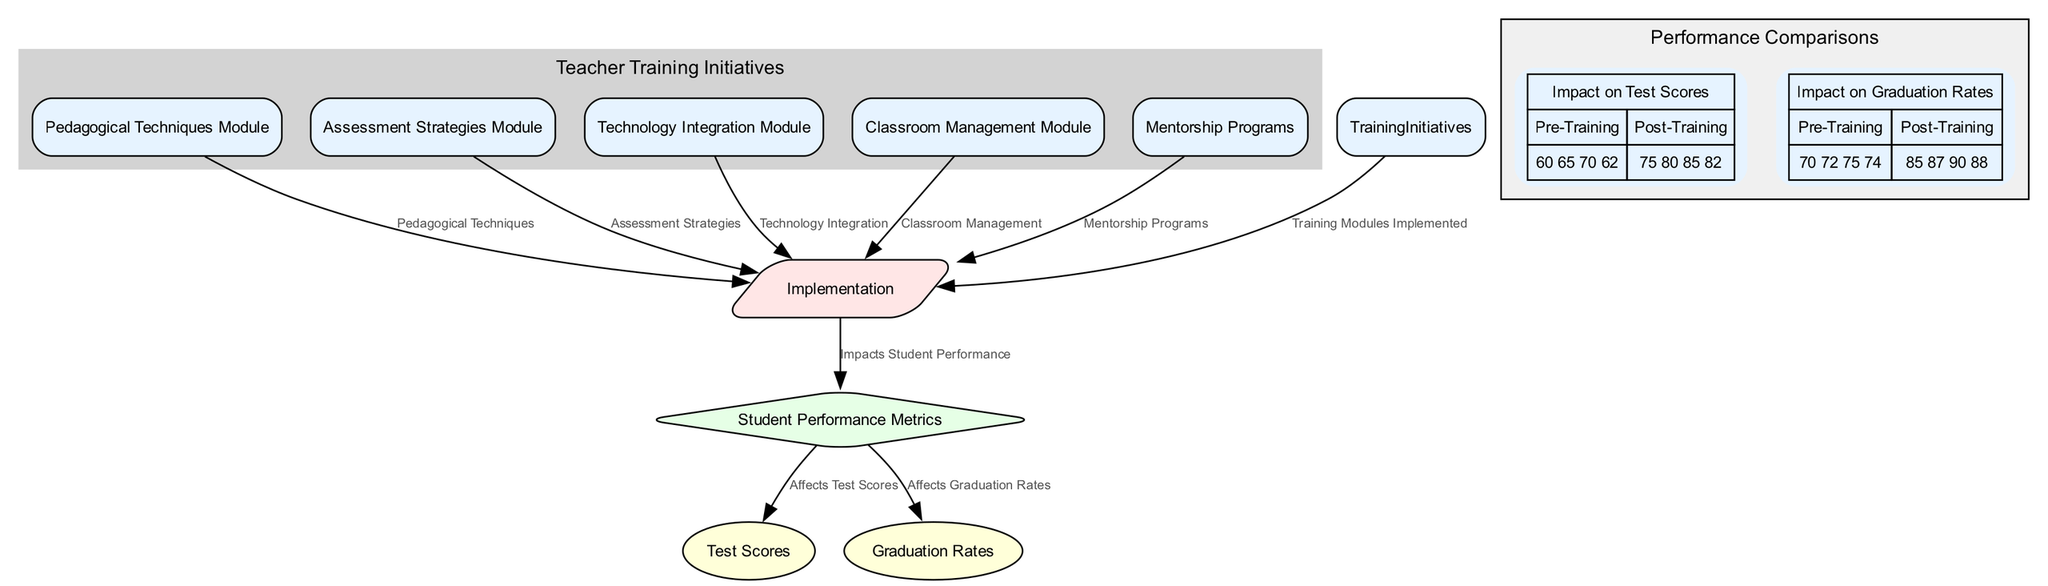What are the five training modules listed? The diagram outlines five specific training modules: Pedagogical Techniques Module, Assessment Strategies Module, Technology Integration Module, Classroom Management Module, and Mentorship Programs. These can be found in the section labeled "Teacher Training Initiatives".
Answer: Pedagogical Techniques Module, Assessment Strategies Module, Technology Integration Module, Classroom Management Module, Mentorship Programs How many edges are present in the diagram? To find the total number of edges, count each connection made between nodes. The edges include connections from each training module to Implementation, from Implementation to Student Performance, and from Student Performance to Test Scores and Graduation Rates. In total, there are 8 edges.
Answer: 8 What does the Implementation node connect to? The Implementation node connects to the Student Performance node, indicating that the training initiatives directly impact student performance metrics.
Answer: Student Performance What is the impact of Training Initiatives on student performance? The diagram shows that Training Initiatives through the Implementation phase have a direct effect on Student Performance Metrics, indicating a positive relationship found in the edges leading from Implementation to Student Performance.
Answer: Impacts Student Performance What were the pre-training average test scores from the chart? The pre-training average test scores can be calculated by using the provided values from the "Impact on Test Scores" chart, which lists them as 60, 65, 70, and 62. The average of these values is calculated as follows: (60 + 65 + 70 + 62) / 4 = 64.25.
Answer: 64.25 How did the graduation rates change post-training? Looking at the "Impact on Graduation Rates" chart, the graduation rates before training were 70, 72, 75, and 74, while after training they rose to 85, 87, 90, and 88, indicating a substantial improvement.
Answer: Increased What is the shape of the Implementation node in the diagram? The Implementation node is represented as a parallelogram in the diagram, which is a specific shape used to indicate steps in a process or actions being taken.
Answer: Parallelogram What is the description of the Technology Integration Module? The Technology Integration Module focuses on training teachers to effectively use technology in the classroom, as explained in the section for Teacher Training Initiatives.
Answer: Training on using technology effectively in the classroom 